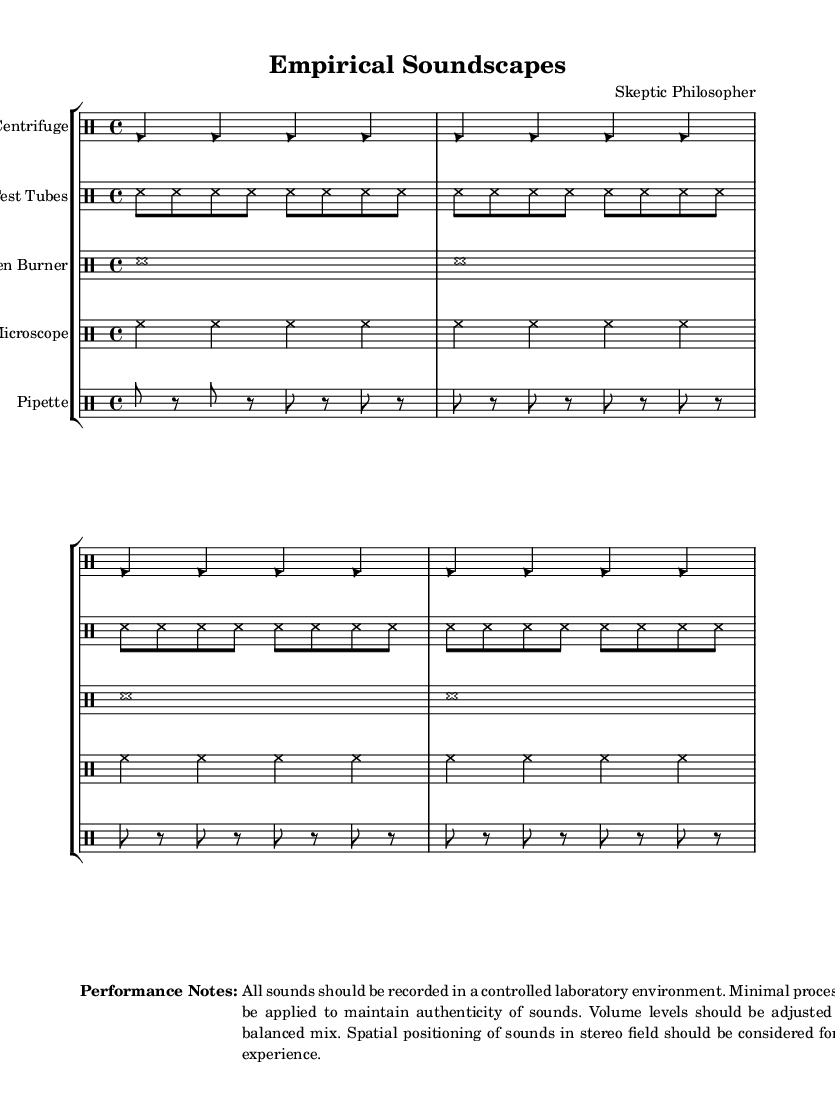What instruments are used in this composition? The sheet music indicates five drum staffs named after laboratory equipment: Centrifuge, Test Tubes, Bunsen Burner, Microscope, and Pipette.
Answer: Centrifuge, Test Tubes, Bunsen Burner, Microscope, Pipette What is the time signature of the music? Each segment of the drum patterns shows that they repeat every four beats, indicating a standard measure, which usually implies a 4/4 time signature.
Answer: 4/4 How many measures does the centrifuge part consist of? The centrifuge section consists of four measures, each using the same pattern that is repeated for clarity.
Answer: 4 What type of note heads are used for the test tubes? The note heads for the test tubes are represented as crosses, indicating their specific sound or representation within the score.
Answer: Cross What is the main instruction for recording the sounds? The performance notes specify that all sounds should be recorded in a controlled laboratory environment to ensure authenticity of the sounds produced.
Answer: Controlled laboratory environment Which percussion instruments have similar rhythmic patterns? The test tubes and microscope parts both follow a consistent pattern within their measures, making their rhythms quite similar across four measures.
Answer: Test Tubes, Microscope 